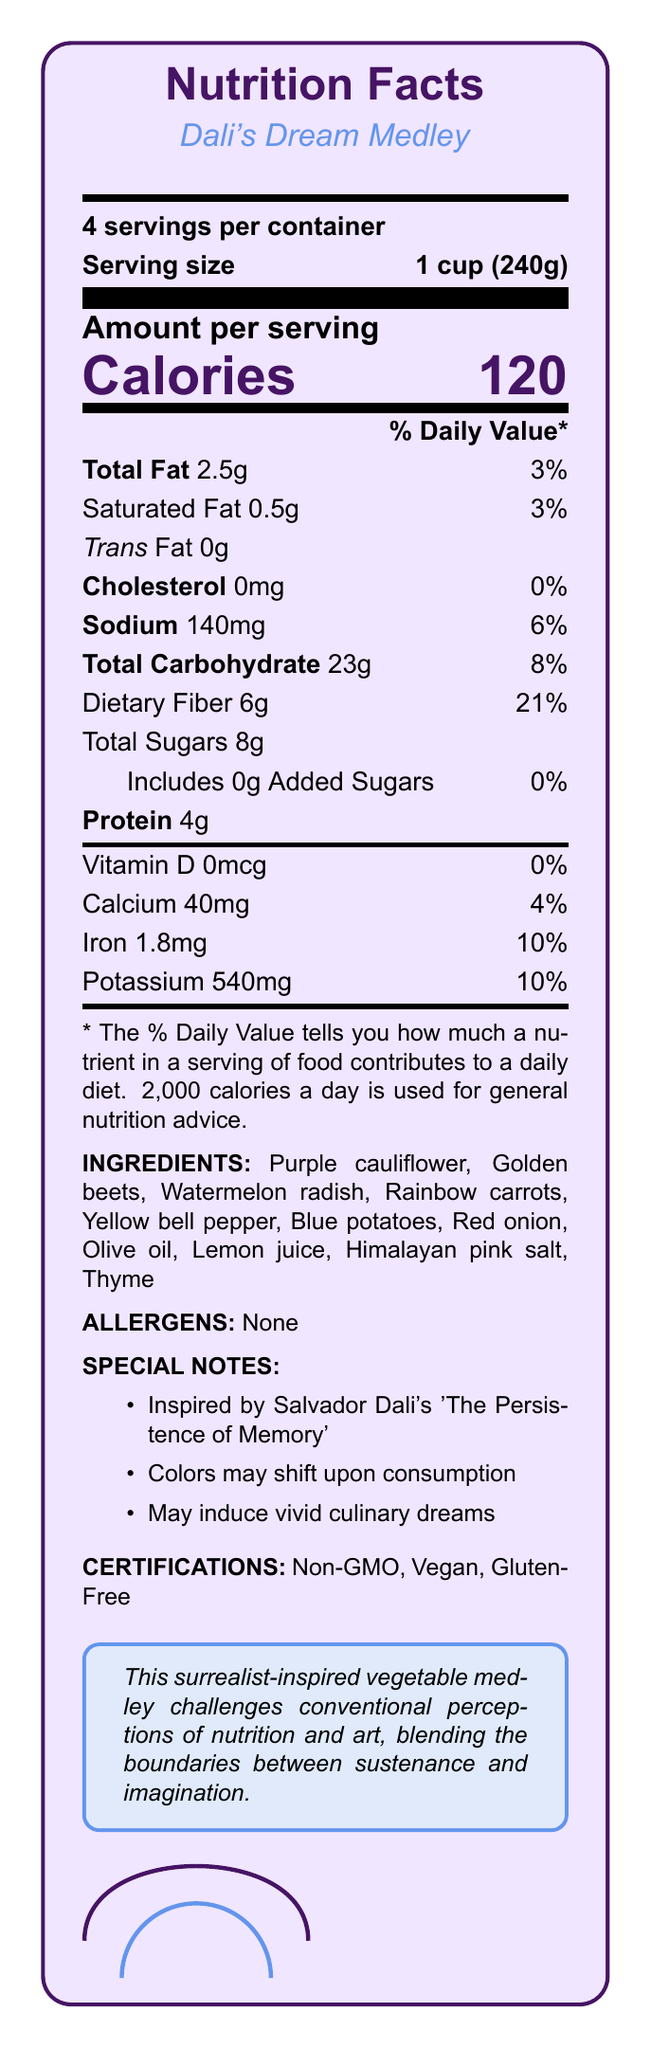what is the serving size of the product? The serving size is explicitly stated as "1 cup (240g)" in the document.
Answer: 1 cup (240g) how many calories are there per serving? The document clearly lists the number of calories per serving as 120.
Answer: 120 how much dietary fiber is in one serving? Dietary fiber content per serving is specified as 6g in the document.
Answer: 6g which ingredient in the medley is used for seasoning? Among the ingredients listed, Himalayan pink salt is used for seasoning.
Answer: Himalayan pink salt what certifications does this product have? The certifications are listed in the "CERTIFICATIONS" section of the document.
Answer: Non-GMO, Vegan, Gluten-Free how many grams of total fat are in one serving? The document states that one serving contains 2.5g of total fat.
Answer: 2.5g what percentage of the daily value for iron does one serving provide? The daily value percentage for iron in one serving is 10%, as detailed in the document.
Answer: 10% does this product contain any allergens? The document specifies "None" under the ALLERGENS section, indicating there are no allergens.
Answer: No how many servings are there per container? The document lists "4 servings per container."
Answer: 4 which of the following ingredients is NOT part of the vegetable medley?
A. Purple cauliflower
B. Golden beets
C. Broccoli
D. Blue potatoes Broccoli is not listed among the ingredients; the other options are.
Answer: C. Broccoli what artistic inspiration is mentioned for this dish? The document notes that the dish is inspired by Salvador Dali's 'The Persistence of Memory'.
Answer: Salvador Dali's 'The Persistence of Memory' what total amount of protein does the entire container hold? Since one serving contains 4g of protein and there are 4 servings in total, the whole container holds 16g of protein.
Answer: 16g what special note is given about consuming the product? One of the special notes mentions that colors may shift upon consumption.
Answer: Colors may shift upon consumption is this product suitable for someone on a gluten-free diet? The product is certified gluten-free according to the document.
Answer: Yes how many grams of added sugars does one serving contain? The document specifies that there are 0g of added sugars in one serving.
Answer: 0g summarize the main idea of the document. This summary concisely captures the essential points of the nutrition facts, ingredients, special notes, and certifications presented in the document.
Answer: The document provides nutritional information for "Dali's Dream Medley," a surrealist-inspired vegetable medley with 4 servings per container, featuring bright ingredients and special notes related to its artistic inspiration. The product is Non-GMO, Vegan, and Gluten-Free. is the vegetable medley high in sodium? With 140mg of sodium per serving, it accounts for 6% of the daily value, which is relatively low.
Answer: No how much potassium is there per serving? The amount of potassium per serving is listed as 540mg in the document.
Answer: 540mg what effect might the medley have according to the special notes? The document states that the medley may induce vivid culinary dreams.
Answer: It may induce vivid culinary dreams what inspired the vegetable medley? The product is inspired by Salvador Dali's surrealist artwork 'The Persistence of Memory,' as noted in the special notes section.
Answer: Salvador Dali's 'The Persistence of Memory' can we determine the cost of the product from this document? The document does not provide any pricing information about the product.
Answer: Cannot be determined 